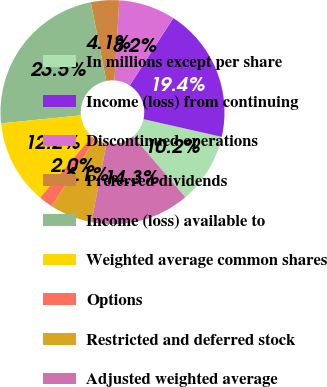Convert chart. <chart><loc_0><loc_0><loc_500><loc_500><pie_chart><fcel>In millions except per share<fcel>Income (loss) from continuing<fcel>Discontinued operations<fcel>Preferred dividends<fcel>Income (loss) available to<fcel>Weighted average common shares<fcel>Options<fcel>Restricted and deferred stock<fcel>Adjusted weighted average<nl><fcel>10.19%<fcel>19.41%<fcel>8.16%<fcel>4.08%<fcel>23.49%<fcel>12.23%<fcel>2.04%<fcel>6.12%<fcel>14.27%<nl></chart> 